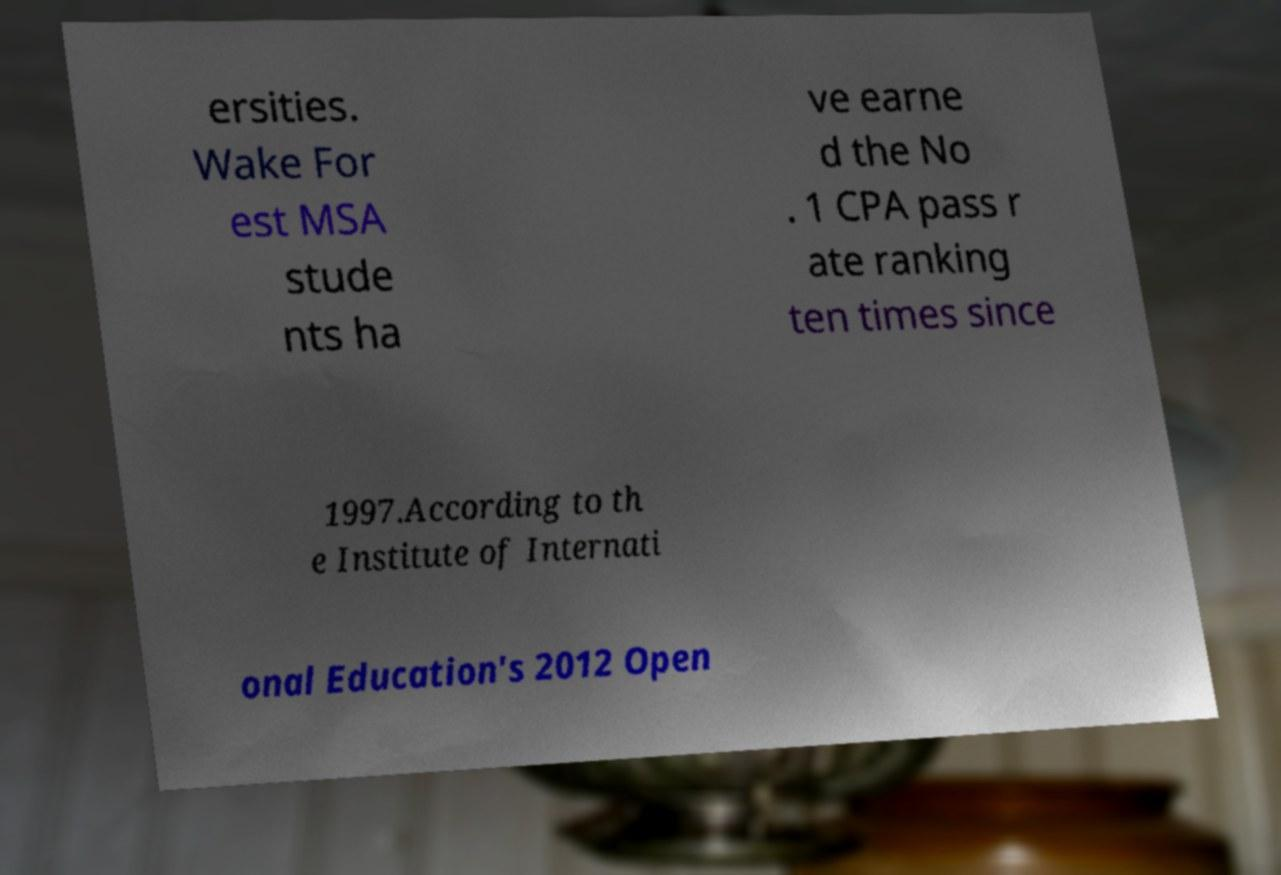For documentation purposes, I need the text within this image transcribed. Could you provide that? ersities. Wake For est MSA stude nts ha ve earne d the No . 1 CPA pass r ate ranking ten times since 1997.According to th e Institute of Internati onal Education's 2012 Open 